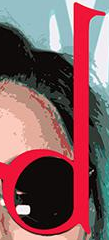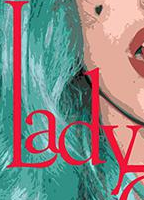What words can you see in these images in sequence, separated by a semicolon? d; Lady 